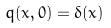<formula> <loc_0><loc_0><loc_500><loc_500>q ( x , 0 ) = \delta ( x )</formula> 